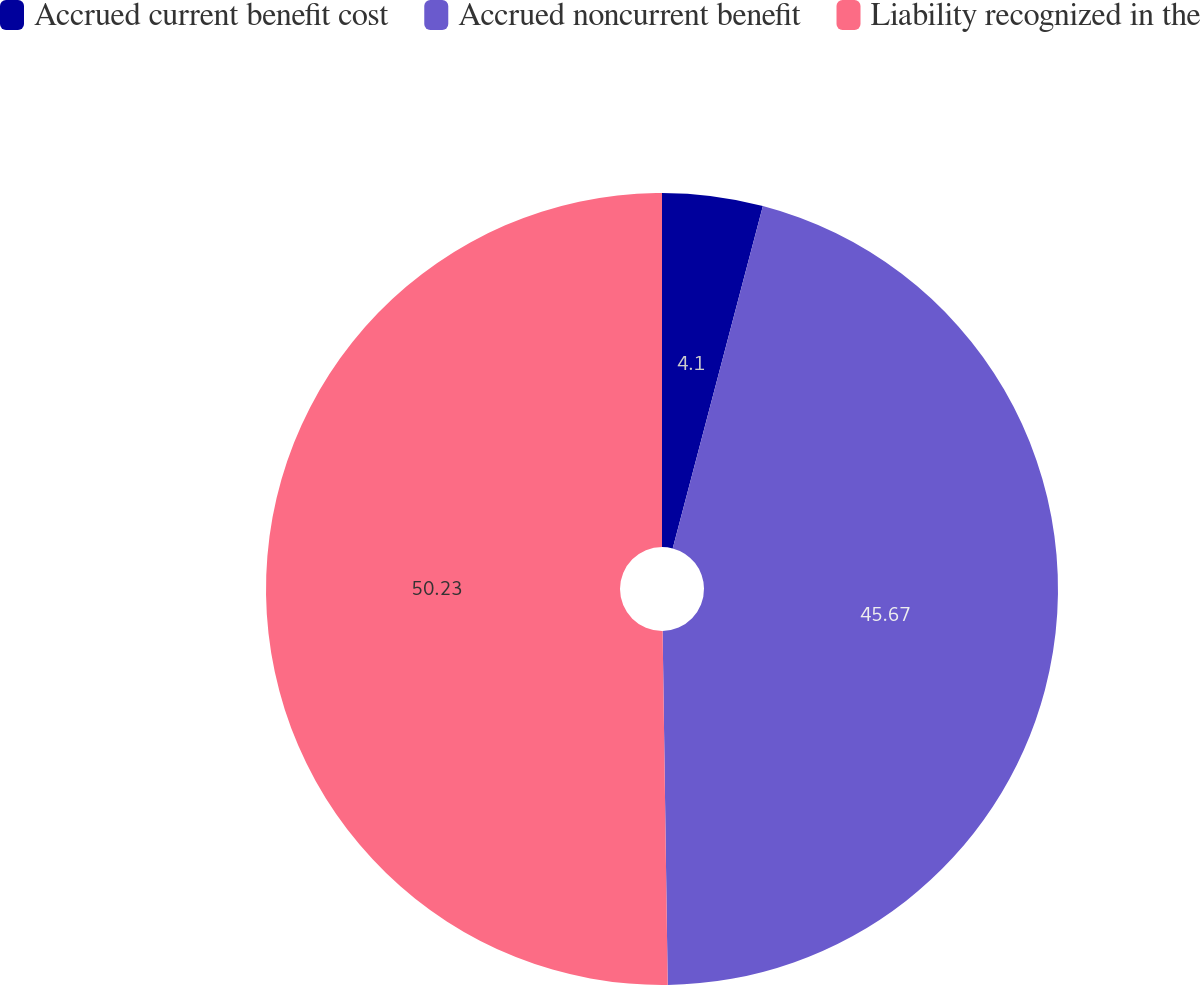<chart> <loc_0><loc_0><loc_500><loc_500><pie_chart><fcel>Accrued current benefit cost<fcel>Accrued noncurrent benefit<fcel>Liability recognized in the<nl><fcel>4.1%<fcel>45.67%<fcel>50.23%<nl></chart> 